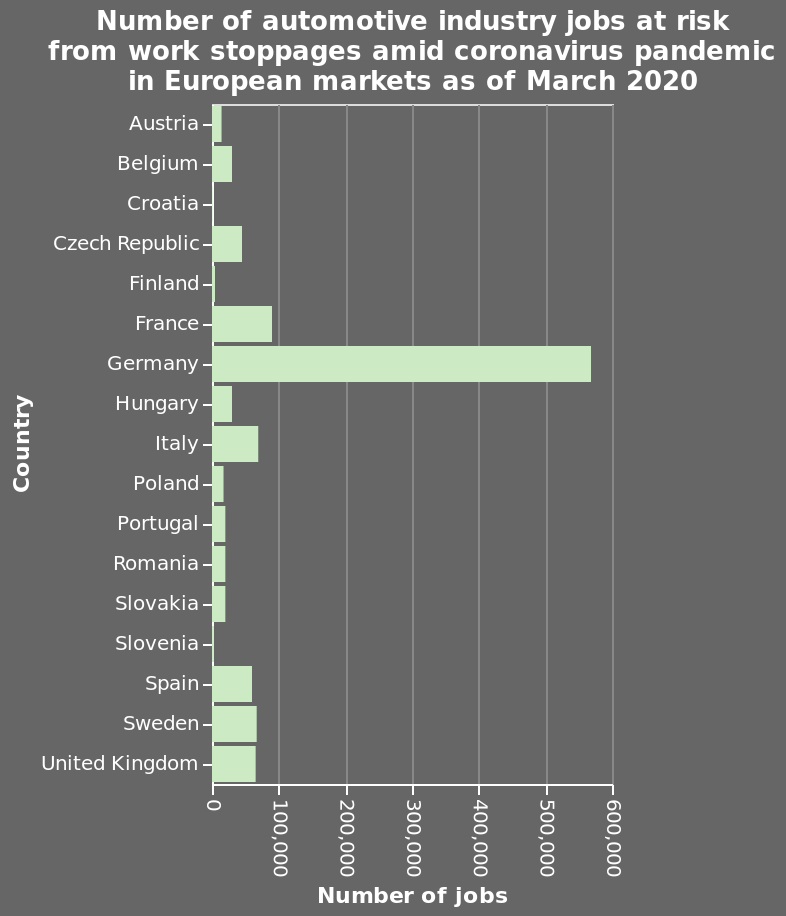<image>
What was the range of the number of jobs at risk for countries other than Germany? The number of jobs at risk for countries other than Germany was between 20,000 and 90,000. Which country had the highest number of automotive jobs at risk?  Germany had the highest number of automotive jobs at risk. 